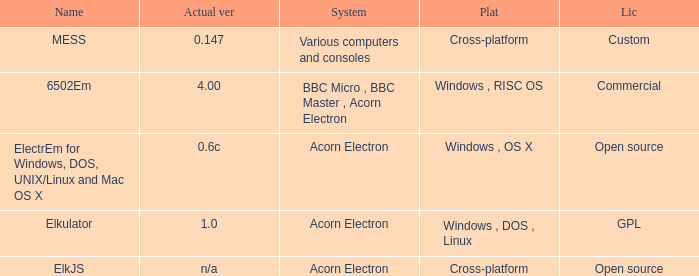Which system is named ELKJS? Acorn Electron. 